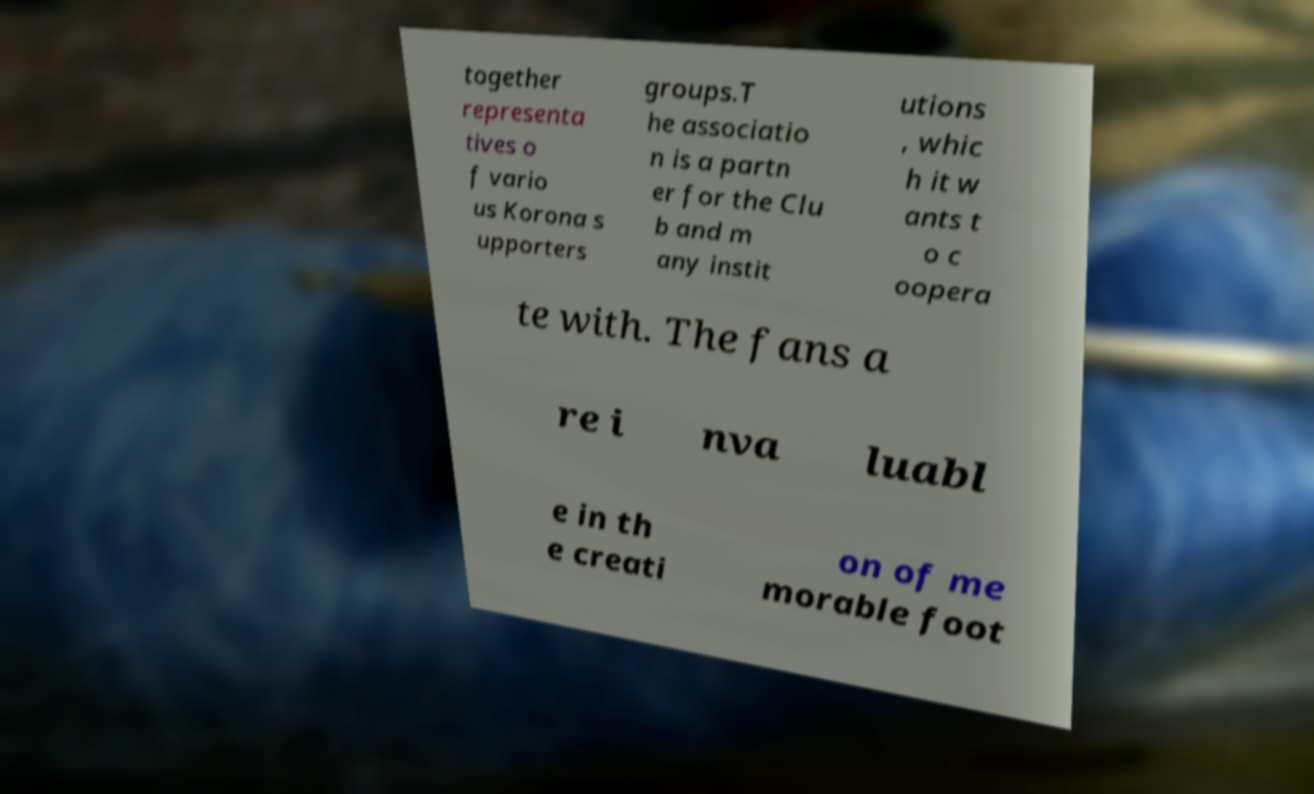Please read and relay the text visible in this image. What does it say? together representa tives o f vario us Korona s upporters groups.T he associatio n is a partn er for the Clu b and m any instit utions , whic h it w ants t o c oopera te with. The fans a re i nva luabl e in th e creati on of me morable foot 